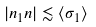<formula> <loc_0><loc_0><loc_500><loc_500>| n _ { 1 } n | \lesssim \langle \sigma _ { 1 } \rangle</formula> 